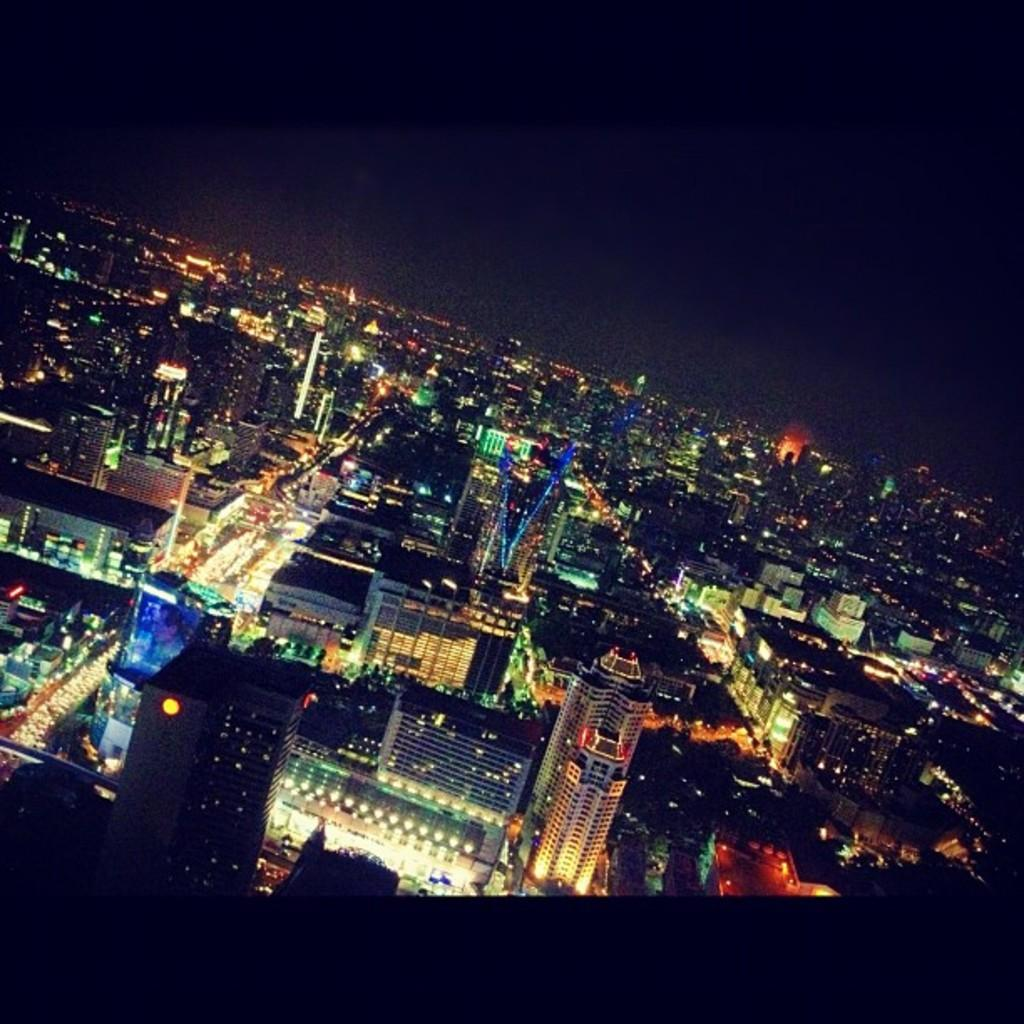What type of location is shown in the image? The image depicts a city. What can be seen in the center of the image? There are skyscrapers, buildings, roads, and lights visible in the center of the image. What is the condition of the top of the image? The top of the image appears to be dark. What time of day is it in the image, based on the hour hand of the clock tower? There is no clock tower present in the image, so it is not possible to determine the time of day based on an hour hand. 